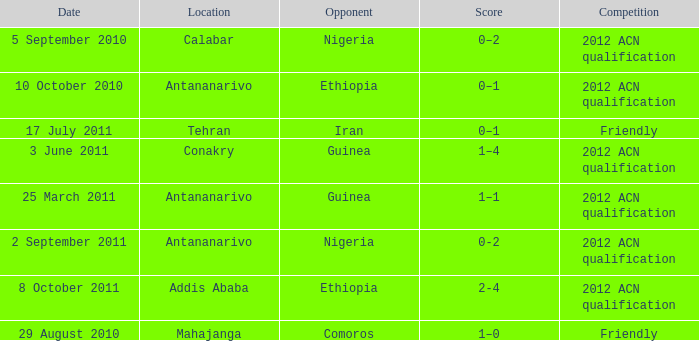Which competition was held at Addis Ababa? 2012 ACN qualification. 